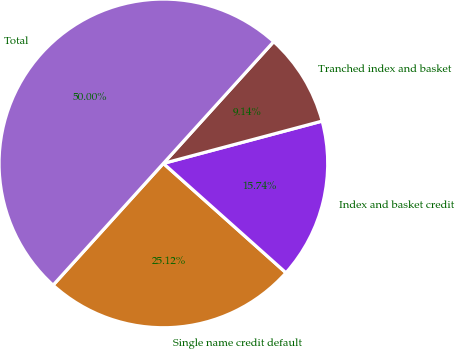Convert chart to OTSL. <chart><loc_0><loc_0><loc_500><loc_500><pie_chart><fcel>Single name credit default<fcel>Index and basket credit<fcel>Tranched index and basket<fcel>Total<nl><fcel>25.12%<fcel>15.74%<fcel>9.14%<fcel>50.0%<nl></chart> 